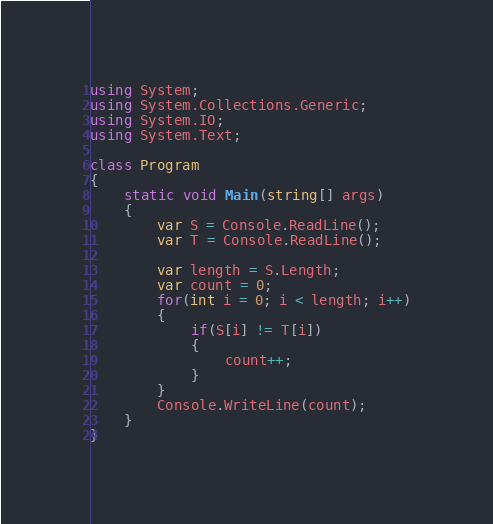<code> <loc_0><loc_0><loc_500><loc_500><_C#_>using System;
using System.Collections.Generic;
using System.IO;
using System.Text;

class Program
{
    static void Main(string[] args)
    {
        var S = Console.ReadLine();
        var T = Console.ReadLine();

        var length = S.Length;
        var count = 0;
        for(int i = 0; i < length; i++)
        {
            if(S[i] != T[i])
            {
                count++;
            }
        }
        Console.WriteLine(count);
    }
}
</code> 